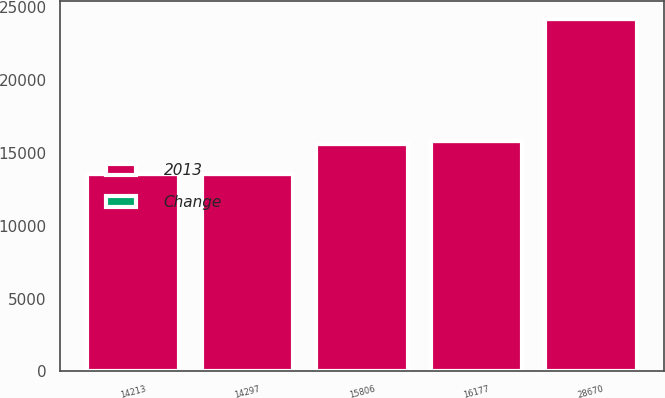Convert chart. <chart><loc_0><loc_0><loc_500><loc_500><stacked_bar_chart><ecel><fcel>14213<fcel>28670<fcel>14297<fcel>16177<fcel>15806<nl><fcel>2013<fcel>13514<fcel>24155<fcel>13566<fcel>15806<fcel>15601<nl><fcel>Change<fcel>5<fcel>19<fcel>5<fcel>2<fcel>1<nl></chart> 